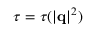Convert formula to latex. <formula><loc_0><loc_0><loc_500><loc_500>\tau = \tau ( | \mathbf q | ^ { 2 } )</formula> 